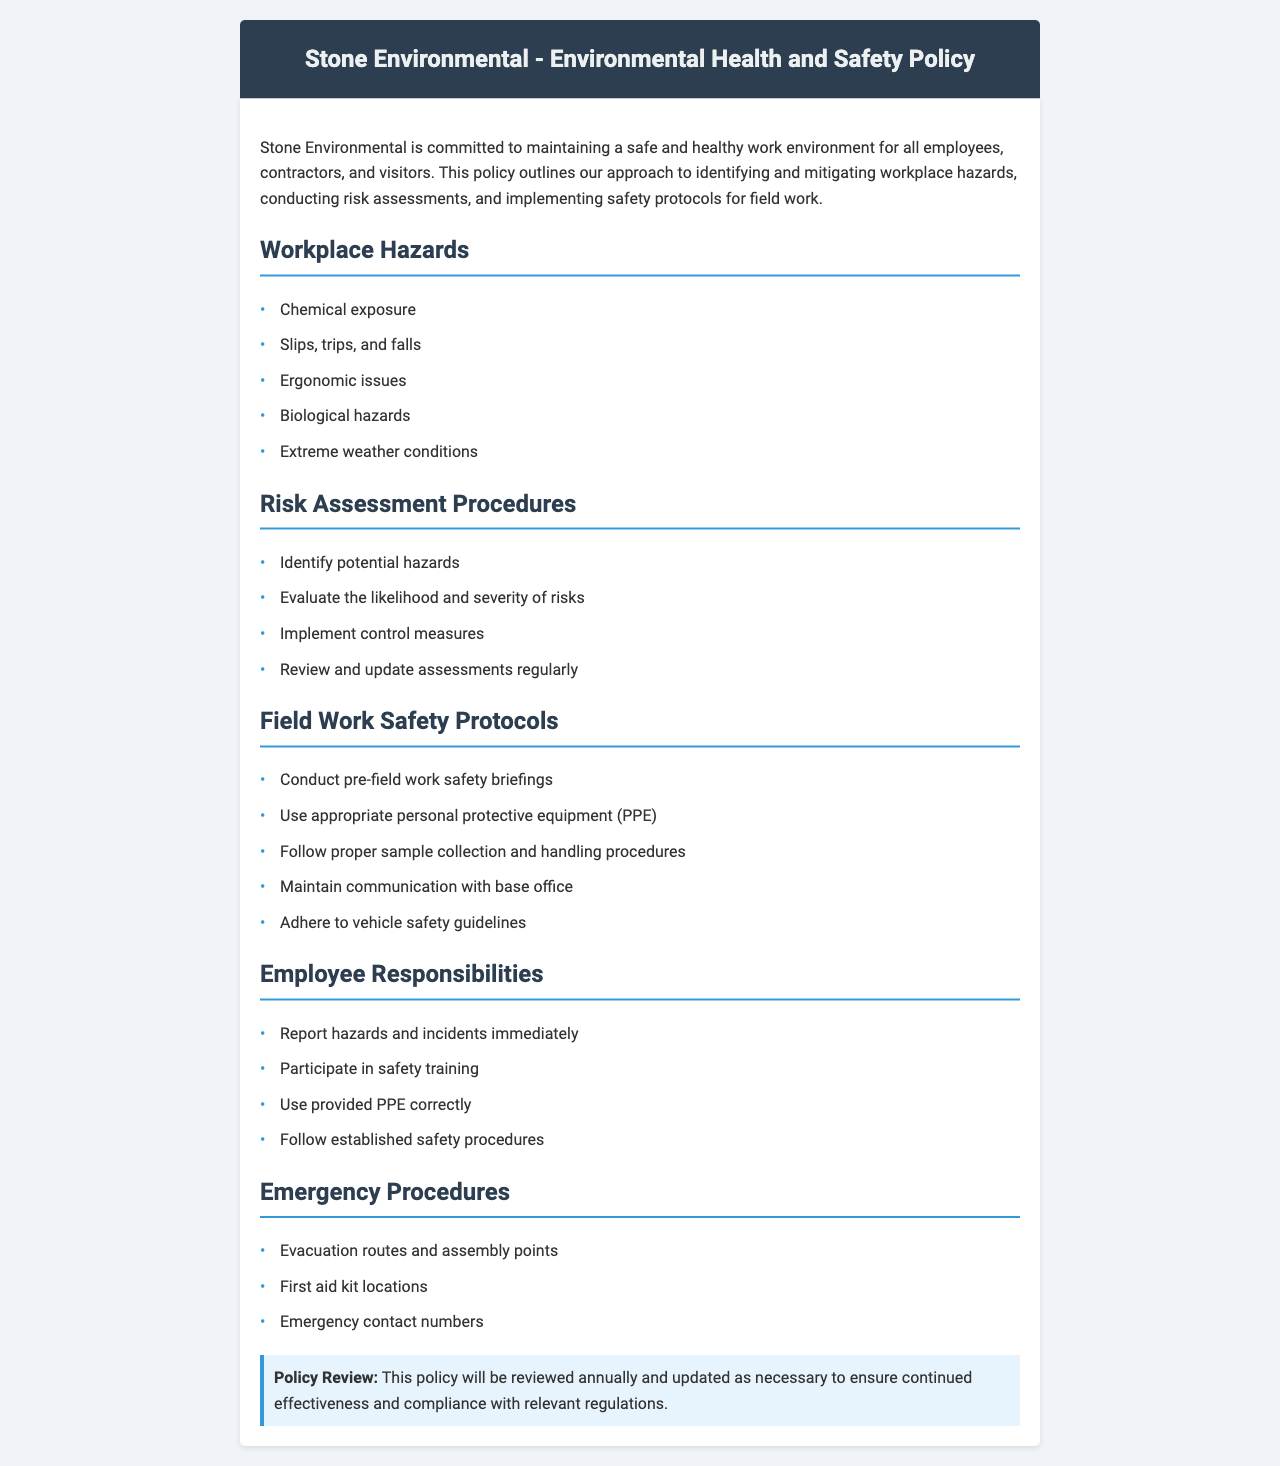What are the types of workplace hazards identified? The document lists specific workplace hazards to be aware of, including chemical exposure and ergonomic issues.
Answer: Chemical exposure, slips, trips, and falls, ergonomic issues, biological hazards, extreme weather conditions What is the first step in the risk assessment procedures? The first step in the risk assessment procedures is to identify potential hazards.
Answer: Identify potential hazards What should be used during field work for safety? The safety protocols mention using specific equipment to protect workers.
Answer: Appropriate personal protective equipment (PPE) How often will the policy be reviewed? The review frequency is specified in the document to ensure the policy remains effective.
Answer: Annually What should employees do if they see a hazard or incident? The document outlines employee responsibilities, including immediate reporting of issues.
Answer: Report hazards and incidents immediately What is included in the emergency procedures section? The emergency procedures outline specific actions and locations critical for safety.
Answer: Evacuation routes and assembly points, first aid kit locations, emergency contact numbers What is the purpose of pre-field work safety briefings? The briefings are designed to prepare employees before starting field work, emphasizing safety.
Answer: Conduct pre-field work safety briefings Which section outlines employee responsibilities? The document includes a dedicated section that describes what each employee is responsible for regarding safety.
Answer: Employee Responsibilities 